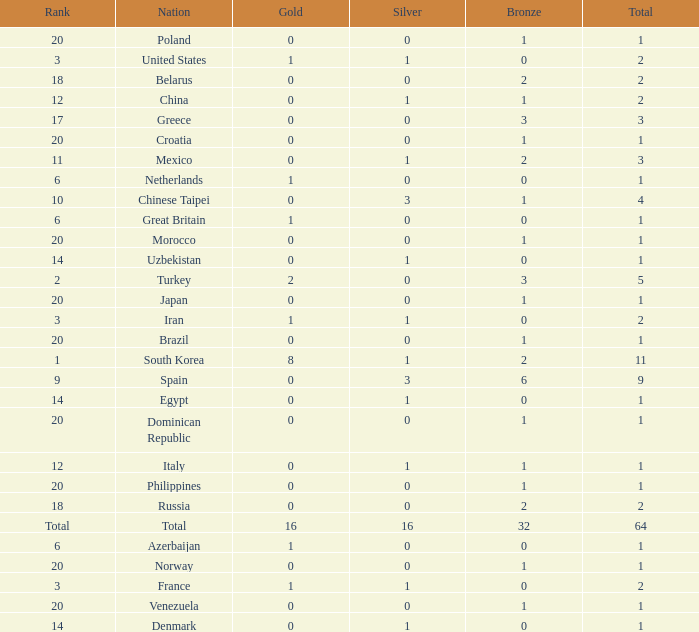What is the lowest number of gold medals the nation with less than 0 silver medals has? None. 